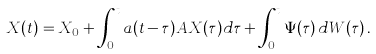Convert formula to latex. <formula><loc_0><loc_0><loc_500><loc_500>X ( t ) = X _ { 0 } + \int _ { 0 } ^ { t } a ( t - \tau ) A X ( \tau ) d \tau + \int _ { 0 } ^ { t } \Psi ( \tau ) \, d W ( \tau ) \, .</formula> 